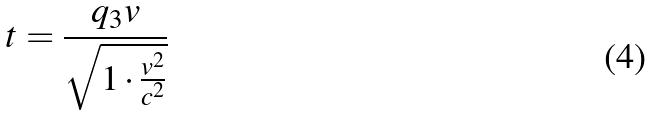Convert formula to latex. <formula><loc_0><loc_0><loc_500><loc_500>t = \frac { q _ { 3 } v } { \sqrt { 1 \cdot \frac { v ^ { 2 } } { c ^ { 2 } } } }</formula> 